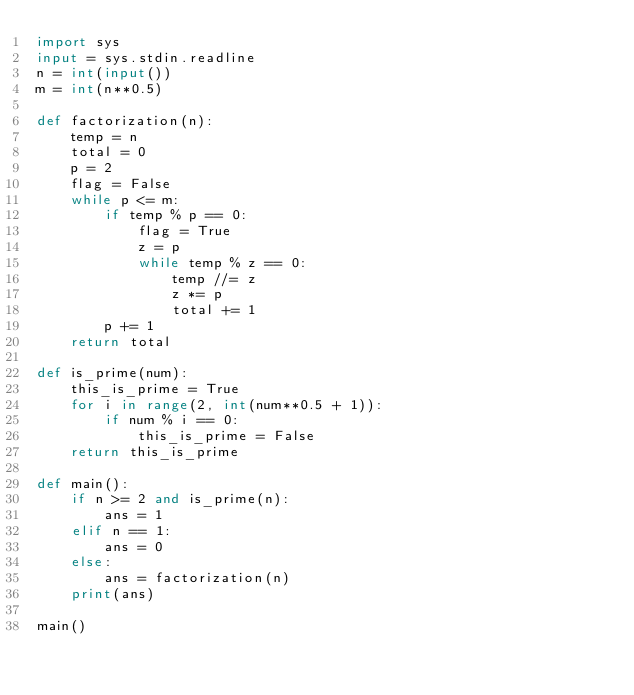Convert code to text. <code><loc_0><loc_0><loc_500><loc_500><_Python_>import sys 
input = sys.stdin.readline
n = int(input())
m = int(n**0.5)

def factorization(n):
    temp = n
    total = 0
    p = 2
    flag = False
    while p <= m:
        if temp % p == 0:
            flag = True
            z = p
            while temp % z == 0:
                temp //= z
                z *= p
                total += 1        
        p += 1
    return total

def is_prime(num):
    this_is_prime = True
    for i in range(2, int(num**0.5 + 1)):
        if num % i == 0:
            this_is_prime = False
    return this_is_prime

def main():
    if n >= 2 and is_prime(n):
        ans = 1
    elif n == 1:
        ans = 0
    else:
        ans = factorization(n)
    print(ans)
    
main()</code> 